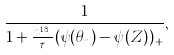Convert formula to latex. <formula><loc_0><loc_0><loc_500><loc_500>\frac { 1 } { 1 + \frac { n ^ { 1 / 3 } } { \tau } ( \psi ( \theta _ { n } ) - \psi ( Z ) ) _ { + } } ,</formula> 